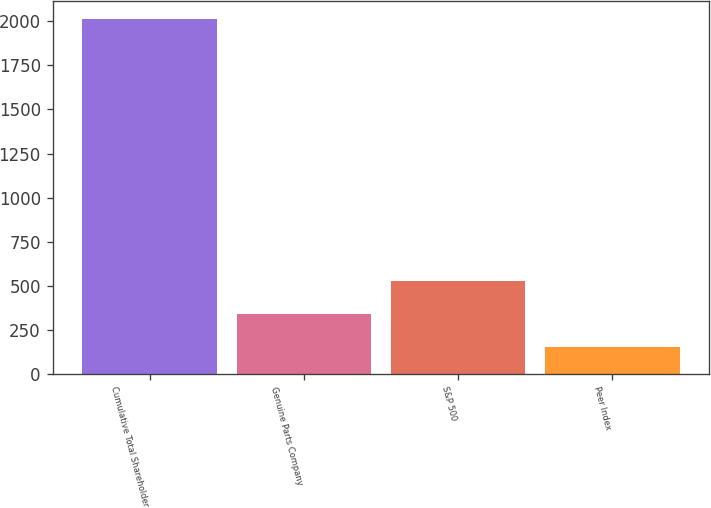Convert chart. <chart><loc_0><loc_0><loc_500><loc_500><bar_chart><fcel>Cumulative Total Shareholder<fcel>Genuine Parts Company<fcel>S&P 500<fcel>Peer Index<nl><fcel>2016<fcel>337.51<fcel>524.01<fcel>151.01<nl></chart> 